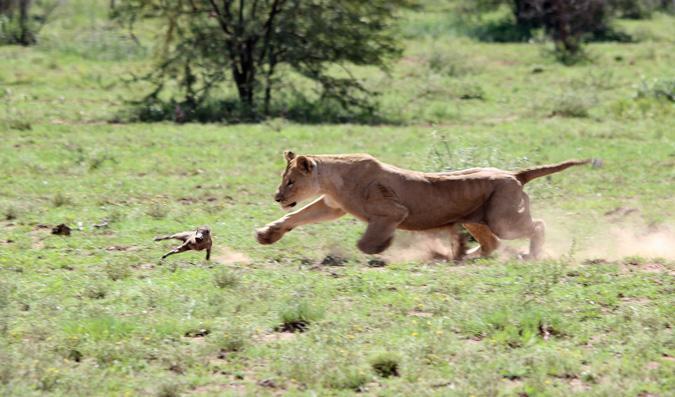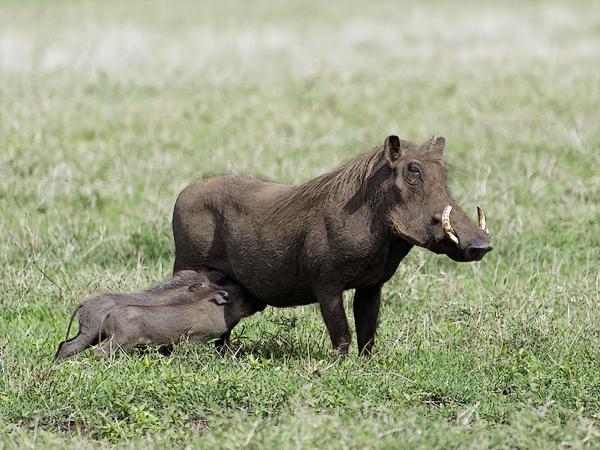The first image is the image on the left, the second image is the image on the right. Given the left and right images, does the statement "An image includes a wild cat and a warthog, and the action scene features kicked-up dust." hold true? Answer yes or no. Yes. The first image is the image on the left, the second image is the image on the right. Analyze the images presented: Is the assertion "The right image contains one adult warthog that is standing beside two baby warthogs." valid? Answer yes or no. Yes. 